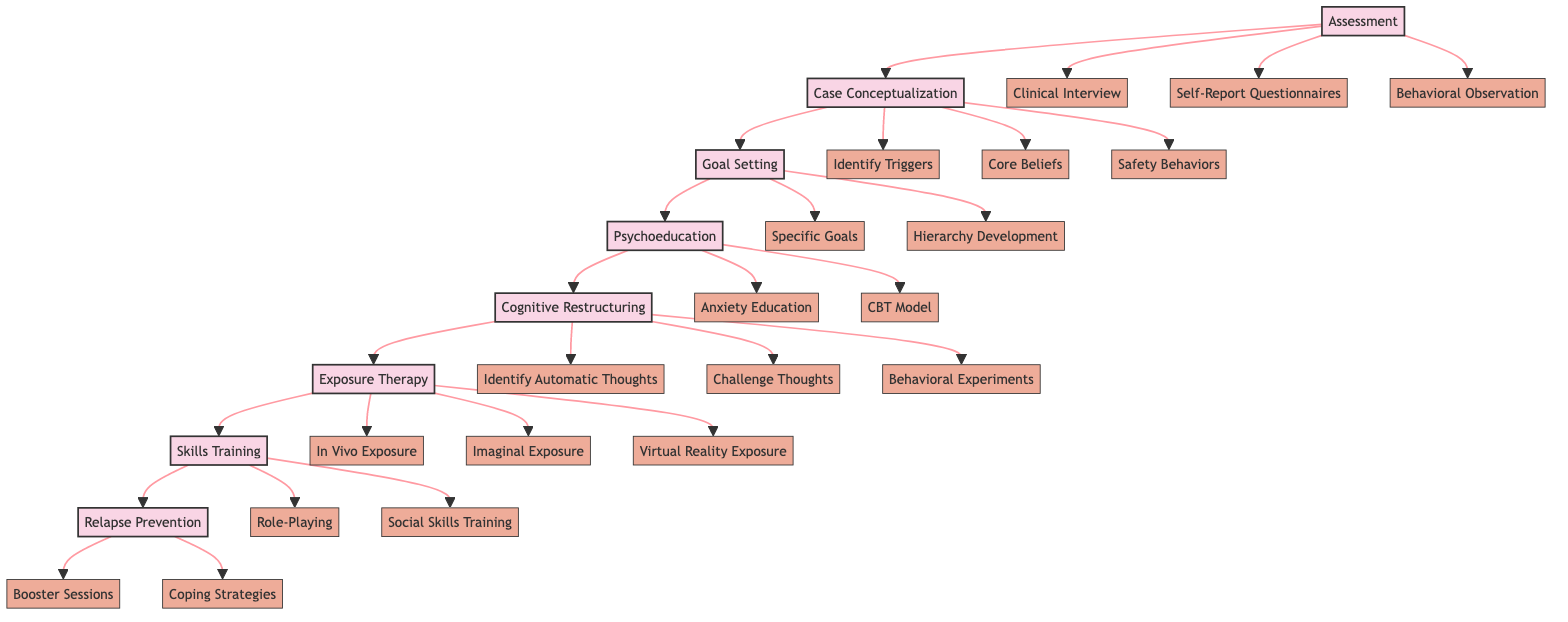What is the first step in the CBT procedure for social anxiety? The diagram starts with the first main step labeled "Assessment," which is visually indicated at the top of the flowchart.
Answer: Assessment How many substeps are under the "Exposure Therapy" step? The "Exposure Therapy" step branches into three substeps: "In Vivo Exposure," "Imaginal Exposure," and "Virtual Reality Exposure," indicating a count of three substeps in total.
Answer: 3 What are the two main substeps of "Goal Setting"? The "Goal Setting" step has two listed substeps: "Specific Goals" and "Hierarchy Development," which can be identified directly from the diagram's arrangement under this main step.
Answer: Specific Goals, Hierarchy Development What is the last step in the CBT procedure? The flowchart concludes with "Relapse Prevention," as it is positioned at the end of the sequence in the diagram.
Answer: Relapse Prevention Which main step comes after "Cognitive Restructuring"? Following the flow of the diagram, the main step that comes after "Cognitive Restructuring" is "Exposure Therapy," shown as the direct connection in the flow between these two steps.
Answer: Exposure Therapy What is the goal of the "Psychoeducation" step? The goal of "Psychoeducation" is to educate the patient about social anxiety and CBT, as described in the diagram next to the main step.
Answer: Educating the patient about social anxiety and CBT What type of exposure is used in the "Exposure Therapy" step? The "Exposure Therapy" step includes "In Vivo Exposure," which indicates that this method of real-life social situations is specifically employed within this step.
Answer: In Vivo Exposure What are the two components of "Relapse Prevention"? The "Relapse Prevention" step is comprised of two components: "Booster Sessions" and "Coping Strategies," which are listed as substeps under this main step in the diagram.
Answer: Booster Sessions, Coping Strategies 